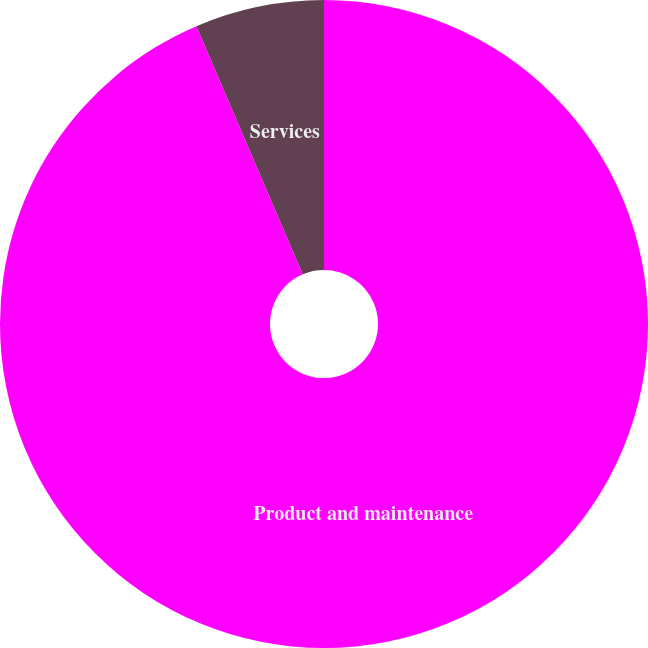<chart> <loc_0><loc_0><loc_500><loc_500><pie_chart><fcel>Product and maintenance<fcel>Services<nl><fcel>93.56%<fcel>6.44%<nl></chart> 